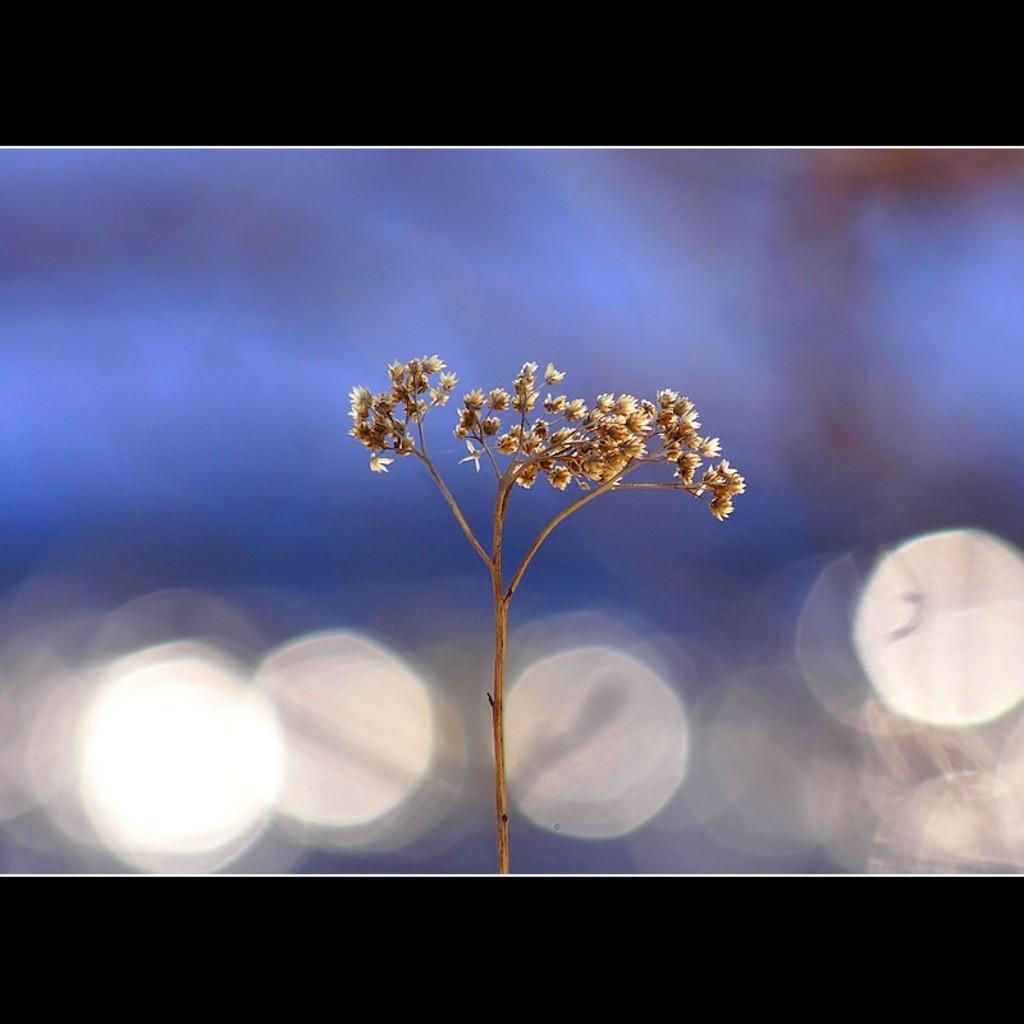Can you describe this image briefly? In this picture we can see a plant, flowers and in the background it is blurry. 